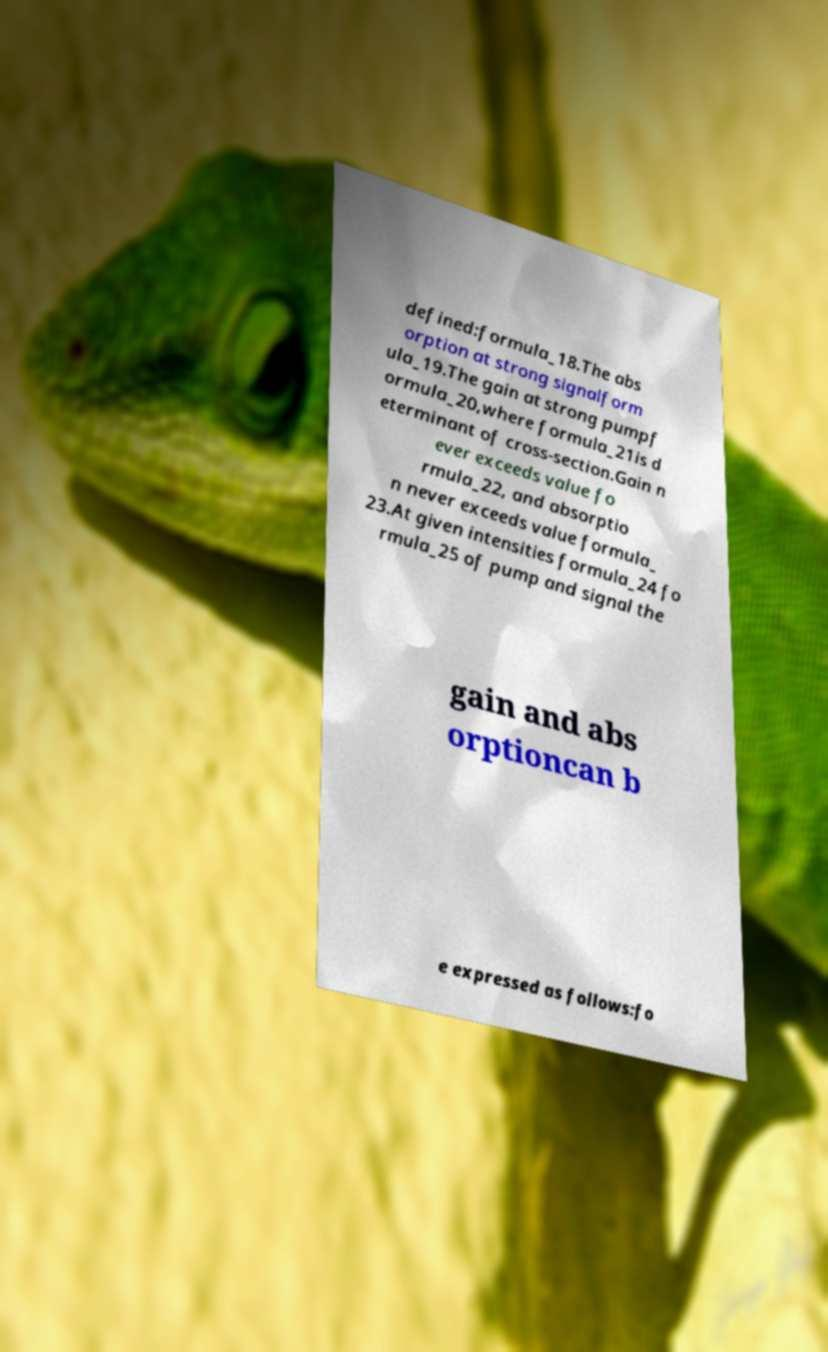What messages or text are displayed in this image? I need them in a readable, typed format. defined:formula_18.The abs orption at strong signalform ula_19.The gain at strong pumpf ormula_20,where formula_21is d eterminant of cross-section.Gain n ever exceeds value fo rmula_22, and absorptio n never exceeds value formula_ 23.At given intensities formula_24 fo rmula_25 of pump and signal the gain and abs orptioncan b e expressed as follows:fo 